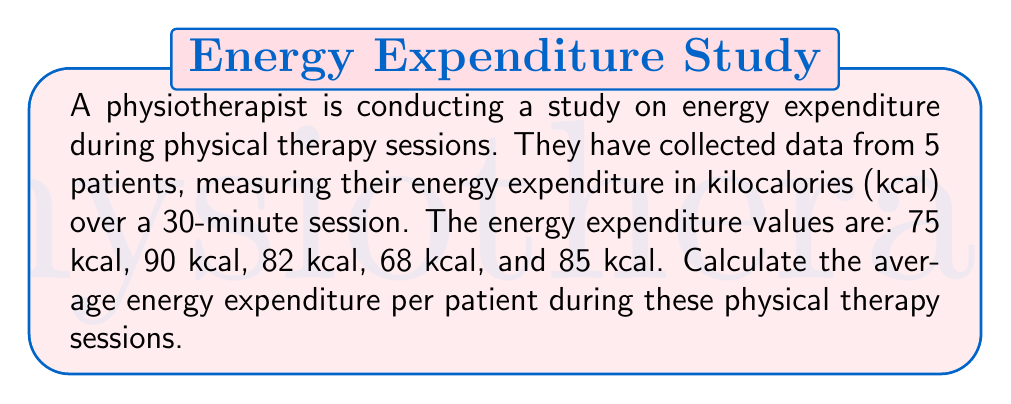Help me with this question. To calculate the average energy expenditure, we need to follow these steps:

1. Sum up all the energy expenditure values:
   $$\text{Total} = 75 + 90 + 82 + 68 + 85 = 400 \text{ kcal}$$

2. Count the number of patients:
   $$n = 5$$

3. Calculate the average by dividing the total by the number of patients:
   $$\text{Average} = \frac{\text{Total}}{n} = \frac{400}{5} = 80 \text{ kcal}$$

Therefore, the average energy expenditure per patient during these 30-minute physical therapy sessions is 80 kcal.
Answer: 80 kcal 